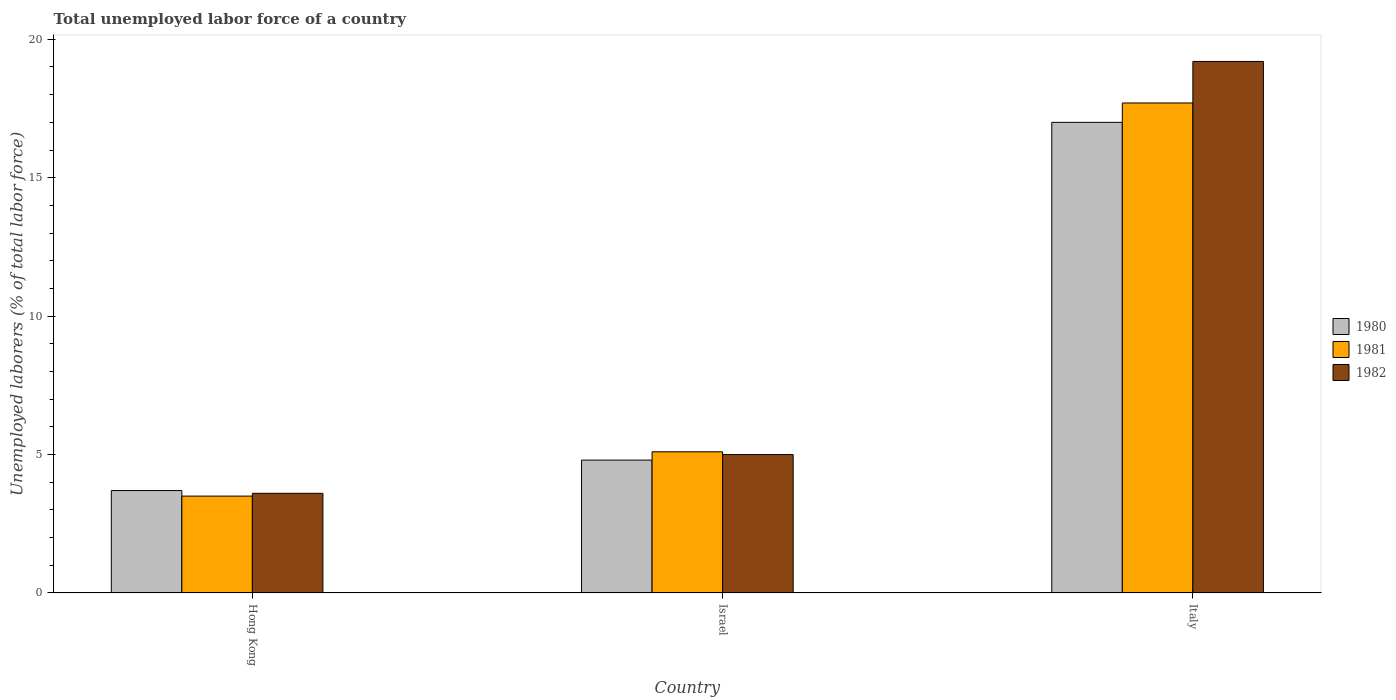How many different coloured bars are there?
Ensure brevity in your answer.  3. How many groups of bars are there?
Give a very brief answer. 3. Are the number of bars per tick equal to the number of legend labels?
Offer a terse response. Yes. How many bars are there on the 3rd tick from the right?
Your answer should be compact. 3. What is the total unemployed labor force in 1982 in Italy?
Make the answer very short. 19.2. Across all countries, what is the maximum total unemployed labor force in 1980?
Your response must be concise. 17. Across all countries, what is the minimum total unemployed labor force in 1982?
Your answer should be compact. 3.6. In which country was the total unemployed labor force in 1980 maximum?
Your response must be concise. Italy. In which country was the total unemployed labor force in 1980 minimum?
Provide a short and direct response. Hong Kong. What is the total total unemployed labor force in 1981 in the graph?
Your response must be concise. 26.3. What is the difference between the total unemployed labor force in 1981 in Israel and that in Italy?
Offer a terse response. -12.6. What is the difference between the total unemployed labor force in 1981 in Israel and the total unemployed labor force in 1980 in Hong Kong?
Offer a very short reply. 1.4. What is the average total unemployed labor force in 1982 per country?
Provide a succinct answer. 9.27. What is the difference between the total unemployed labor force of/in 1980 and total unemployed labor force of/in 1981 in Israel?
Your response must be concise. -0.3. In how many countries, is the total unemployed labor force in 1980 greater than 1 %?
Your response must be concise. 3. What is the ratio of the total unemployed labor force in 1980 in Israel to that in Italy?
Offer a terse response. 0.28. What is the difference between the highest and the second highest total unemployed labor force in 1980?
Provide a short and direct response. 13.3. What is the difference between the highest and the lowest total unemployed labor force in 1982?
Make the answer very short. 15.6. In how many countries, is the total unemployed labor force in 1980 greater than the average total unemployed labor force in 1980 taken over all countries?
Provide a succinct answer. 1. What does the 3rd bar from the left in Israel represents?
Keep it short and to the point. 1982. Is it the case that in every country, the sum of the total unemployed labor force in 1980 and total unemployed labor force in 1982 is greater than the total unemployed labor force in 1981?
Offer a terse response. Yes. How many countries are there in the graph?
Ensure brevity in your answer.  3. Where does the legend appear in the graph?
Offer a very short reply. Center right. How many legend labels are there?
Make the answer very short. 3. What is the title of the graph?
Keep it short and to the point. Total unemployed labor force of a country. What is the label or title of the X-axis?
Offer a very short reply. Country. What is the label or title of the Y-axis?
Keep it short and to the point. Unemployed laborers (% of total labor force). What is the Unemployed laborers (% of total labor force) in 1980 in Hong Kong?
Your answer should be very brief. 3.7. What is the Unemployed laborers (% of total labor force) in 1981 in Hong Kong?
Keep it short and to the point. 3.5. What is the Unemployed laborers (% of total labor force) in 1982 in Hong Kong?
Offer a very short reply. 3.6. What is the Unemployed laborers (% of total labor force) of 1980 in Israel?
Offer a very short reply. 4.8. What is the Unemployed laborers (% of total labor force) in 1981 in Israel?
Provide a short and direct response. 5.1. What is the Unemployed laborers (% of total labor force) of 1982 in Israel?
Your answer should be very brief. 5. What is the Unemployed laborers (% of total labor force) of 1981 in Italy?
Offer a very short reply. 17.7. What is the Unemployed laborers (% of total labor force) of 1982 in Italy?
Provide a short and direct response. 19.2. Across all countries, what is the maximum Unemployed laborers (% of total labor force) in 1981?
Your answer should be very brief. 17.7. Across all countries, what is the maximum Unemployed laborers (% of total labor force) of 1982?
Ensure brevity in your answer.  19.2. Across all countries, what is the minimum Unemployed laborers (% of total labor force) of 1980?
Make the answer very short. 3.7. Across all countries, what is the minimum Unemployed laborers (% of total labor force) of 1981?
Provide a succinct answer. 3.5. Across all countries, what is the minimum Unemployed laborers (% of total labor force) in 1982?
Offer a terse response. 3.6. What is the total Unemployed laborers (% of total labor force) of 1980 in the graph?
Provide a short and direct response. 25.5. What is the total Unemployed laborers (% of total labor force) of 1981 in the graph?
Give a very brief answer. 26.3. What is the total Unemployed laborers (% of total labor force) of 1982 in the graph?
Provide a short and direct response. 27.8. What is the difference between the Unemployed laborers (% of total labor force) in 1980 in Hong Kong and that in Israel?
Make the answer very short. -1.1. What is the difference between the Unemployed laborers (% of total labor force) of 1981 in Hong Kong and that in Israel?
Ensure brevity in your answer.  -1.6. What is the difference between the Unemployed laborers (% of total labor force) in 1982 in Hong Kong and that in Italy?
Give a very brief answer. -15.6. What is the difference between the Unemployed laborers (% of total labor force) in 1980 in Israel and that in Italy?
Your answer should be compact. -12.2. What is the difference between the Unemployed laborers (% of total labor force) of 1981 in Israel and that in Italy?
Make the answer very short. -12.6. What is the difference between the Unemployed laborers (% of total labor force) in 1982 in Israel and that in Italy?
Offer a terse response. -14.2. What is the difference between the Unemployed laborers (% of total labor force) in 1981 in Hong Kong and the Unemployed laborers (% of total labor force) in 1982 in Israel?
Your answer should be very brief. -1.5. What is the difference between the Unemployed laborers (% of total labor force) of 1980 in Hong Kong and the Unemployed laborers (% of total labor force) of 1982 in Italy?
Keep it short and to the point. -15.5. What is the difference between the Unemployed laborers (% of total labor force) in 1981 in Hong Kong and the Unemployed laborers (% of total labor force) in 1982 in Italy?
Provide a short and direct response. -15.7. What is the difference between the Unemployed laborers (% of total labor force) of 1980 in Israel and the Unemployed laborers (% of total labor force) of 1982 in Italy?
Offer a very short reply. -14.4. What is the difference between the Unemployed laborers (% of total labor force) of 1981 in Israel and the Unemployed laborers (% of total labor force) of 1982 in Italy?
Your response must be concise. -14.1. What is the average Unemployed laborers (% of total labor force) in 1980 per country?
Ensure brevity in your answer.  8.5. What is the average Unemployed laborers (% of total labor force) in 1981 per country?
Make the answer very short. 8.77. What is the average Unemployed laborers (% of total labor force) in 1982 per country?
Offer a terse response. 9.27. What is the difference between the Unemployed laborers (% of total labor force) in 1980 and Unemployed laborers (% of total labor force) in 1982 in Hong Kong?
Provide a short and direct response. 0.1. What is the difference between the Unemployed laborers (% of total labor force) of 1981 and Unemployed laborers (% of total labor force) of 1982 in Hong Kong?
Give a very brief answer. -0.1. What is the difference between the Unemployed laborers (% of total labor force) of 1980 and Unemployed laborers (% of total labor force) of 1981 in Israel?
Ensure brevity in your answer.  -0.3. What is the difference between the Unemployed laborers (% of total labor force) in 1980 and Unemployed laborers (% of total labor force) in 1982 in Israel?
Provide a succinct answer. -0.2. What is the difference between the Unemployed laborers (% of total labor force) in 1981 and Unemployed laborers (% of total labor force) in 1982 in Israel?
Provide a short and direct response. 0.1. What is the difference between the Unemployed laborers (% of total labor force) in 1980 and Unemployed laborers (% of total labor force) in 1981 in Italy?
Your response must be concise. -0.7. What is the difference between the Unemployed laborers (% of total labor force) of 1980 and Unemployed laborers (% of total labor force) of 1982 in Italy?
Your response must be concise. -2.2. What is the ratio of the Unemployed laborers (% of total labor force) of 1980 in Hong Kong to that in Israel?
Your answer should be compact. 0.77. What is the ratio of the Unemployed laborers (% of total labor force) in 1981 in Hong Kong to that in Israel?
Offer a terse response. 0.69. What is the ratio of the Unemployed laborers (% of total labor force) in 1982 in Hong Kong to that in Israel?
Offer a terse response. 0.72. What is the ratio of the Unemployed laborers (% of total labor force) in 1980 in Hong Kong to that in Italy?
Keep it short and to the point. 0.22. What is the ratio of the Unemployed laborers (% of total labor force) in 1981 in Hong Kong to that in Italy?
Ensure brevity in your answer.  0.2. What is the ratio of the Unemployed laborers (% of total labor force) of 1982 in Hong Kong to that in Italy?
Your response must be concise. 0.19. What is the ratio of the Unemployed laborers (% of total labor force) of 1980 in Israel to that in Italy?
Your answer should be compact. 0.28. What is the ratio of the Unemployed laborers (% of total labor force) in 1981 in Israel to that in Italy?
Give a very brief answer. 0.29. What is the ratio of the Unemployed laborers (% of total labor force) in 1982 in Israel to that in Italy?
Offer a very short reply. 0.26. What is the difference between the highest and the second highest Unemployed laborers (% of total labor force) of 1982?
Offer a very short reply. 14.2. What is the difference between the highest and the lowest Unemployed laborers (% of total labor force) in 1980?
Ensure brevity in your answer.  13.3. What is the difference between the highest and the lowest Unemployed laborers (% of total labor force) in 1981?
Offer a very short reply. 14.2. What is the difference between the highest and the lowest Unemployed laborers (% of total labor force) in 1982?
Offer a terse response. 15.6. 